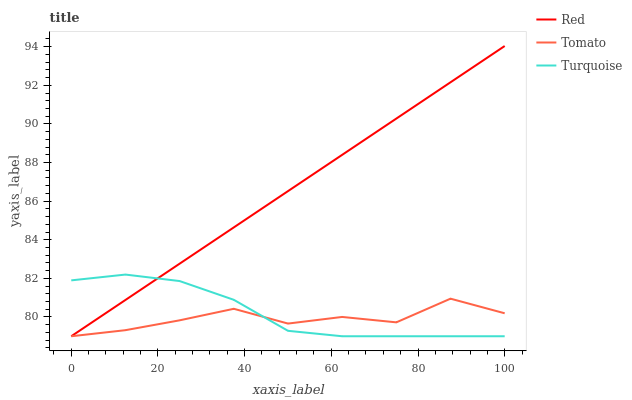Does Tomato have the minimum area under the curve?
Answer yes or no. Yes. Does Red have the maximum area under the curve?
Answer yes or no. Yes. Does Turquoise have the minimum area under the curve?
Answer yes or no. No. Does Turquoise have the maximum area under the curve?
Answer yes or no. No. Is Red the smoothest?
Answer yes or no. Yes. Is Tomato the roughest?
Answer yes or no. Yes. Is Turquoise the smoothest?
Answer yes or no. No. Is Turquoise the roughest?
Answer yes or no. No. Does Tomato have the lowest value?
Answer yes or no. Yes. Does Red have the highest value?
Answer yes or no. Yes. Does Turquoise have the highest value?
Answer yes or no. No. Does Red intersect Turquoise?
Answer yes or no. Yes. Is Red less than Turquoise?
Answer yes or no. No. Is Red greater than Turquoise?
Answer yes or no. No. 